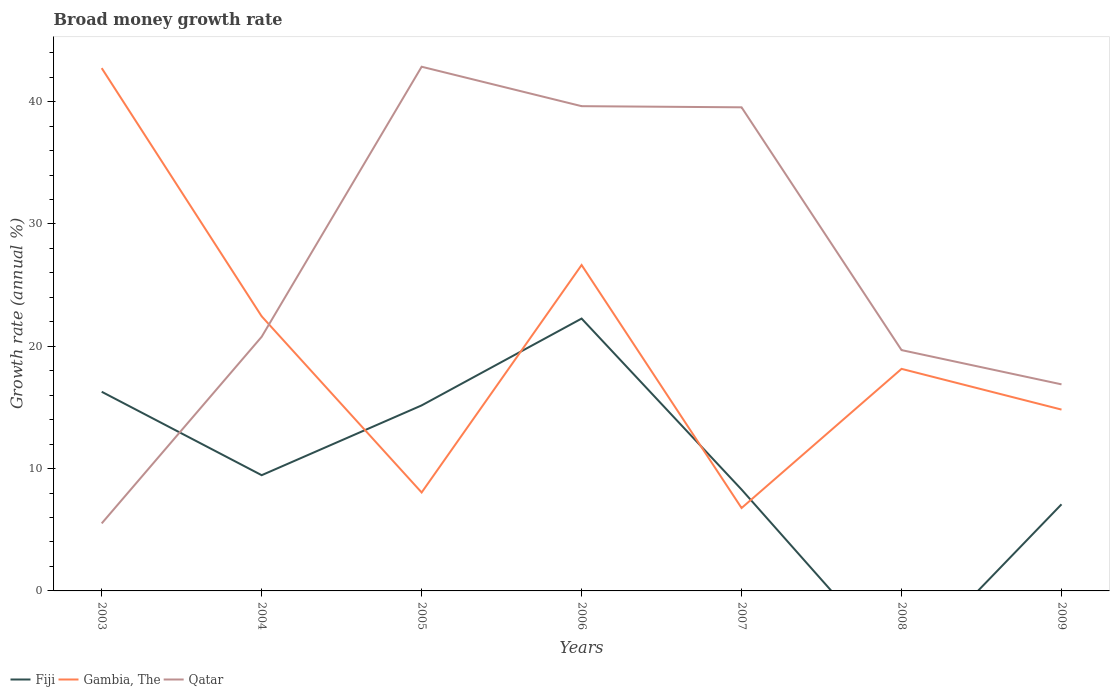Does the line corresponding to Fiji intersect with the line corresponding to Gambia, The?
Offer a terse response. Yes. Is the number of lines equal to the number of legend labels?
Give a very brief answer. No. What is the total growth rate in Gambia, The in the graph?
Provide a succinct answer. 1.27. What is the difference between the highest and the second highest growth rate in Fiji?
Your response must be concise. 22.27. What is the difference between the highest and the lowest growth rate in Fiji?
Keep it short and to the point. 3. How many lines are there?
Keep it short and to the point. 3. Does the graph contain grids?
Your answer should be compact. No. Where does the legend appear in the graph?
Ensure brevity in your answer.  Bottom left. What is the title of the graph?
Offer a very short reply. Broad money growth rate. What is the label or title of the X-axis?
Ensure brevity in your answer.  Years. What is the label or title of the Y-axis?
Keep it short and to the point. Growth rate (annual %). What is the Growth rate (annual %) in Fiji in 2003?
Your response must be concise. 16.28. What is the Growth rate (annual %) in Gambia, The in 2003?
Provide a short and direct response. 42.74. What is the Growth rate (annual %) in Qatar in 2003?
Provide a succinct answer. 5.52. What is the Growth rate (annual %) of Fiji in 2004?
Your answer should be very brief. 9.46. What is the Growth rate (annual %) of Gambia, The in 2004?
Your answer should be very brief. 22.45. What is the Growth rate (annual %) in Qatar in 2004?
Your response must be concise. 20.78. What is the Growth rate (annual %) of Fiji in 2005?
Your response must be concise. 15.17. What is the Growth rate (annual %) in Gambia, The in 2005?
Offer a terse response. 8.05. What is the Growth rate (annual %) in Qatar in 2005?
Ensure brevity in your answer.  42.86. What is the Growth rate (annual %) of Fiji in 2006?
Provide a short and direct response. 22.27. What is the Growth rate (annual %) of Gambia, The in 2006?
Your answer should be very brief. 26.65. What is the Growth rate (annual %) in Qatar in 2006?
Make the answer very short. 39.63. What is the Growth rate (annual %) in Fiji in 2007?
Ensure brevity in your answer.  8.29. What is the Growth rate (annual %) in Gambia, The in 2007?
Your answer should be very brief. 6.78. What is the Growth rate (annual %) of Qatar in 2007?
Your response must be concise. 39.54. What is the Growth rate (annual %) of Fiji in 2008?
Provide a succinct answer. 0. What is the Growth rate (annual %) of Gambia, The in 2008?
Your answer should be very brief. 18.16. What is the Growth rate (annual %) in Qatar in 2008?
Provide a succinct answer. 19.69. What is the Growth rate (annual %) of Fiji in 2009?
Keep it short and to the point. 7.08. What is the Growth rate (annual %) of Gambia, The in 2009?
Offer a very short reply. 14.83. What is the Growth rate (annual %) of Qatar in 2009?
Provide a short and direct response. 16.89. Across all years, what is the maximum Growth rate (annual %) in Fiji?
Keep it short and to the point. 22.27. Across all years, what is the maximum Growth rate (annual %) of Gambia, The?
Your response must be concise. 42.74. Across all years, what is the maximum Growth rate (annual %) of Qatar?
Give a very brief answer. 42.86. Across all years, what is the minimum Growth rate (annual %) of Gambia, The?
Offer a terse response. 6.78. Across all years, what is the minimum Growth rate (annual %) in Qatar?
Make the answer very short. 5.52. What is the total Growth rate (annual %) of Fiji in the graph?
Your answer should be compact. 78.55. What is the total Growth rate (annual %) in Gambia, The in the graph?
Your response must be concise. 139.65. What is the total Growth rate (annual %) of Qatar in the graph?
Keep it short and to the point. 184.91. What is the difference between the Growth rate (annual %) of Fiji in 2003 and that in 2004?
Your answer should be compact. 6.82. What is the difference between the Growth rate (annual %) in Gambia, The in 2003 and that in 2004?
Ensure brevity in your answer.  20.29. What is the difference between the Growth rate (annual %) in Qatar in 2003 and that in 2004?
Provide a short and direct response. -15.26. What is the difference between the Growth rate (annual %) of Fiji in 2003 and that in 2005?
Give a very brief answer. 1.12. What is the difference between the Growth rate (annual %) in Gambia, The in 2003 and that in 2005?
Make the answer very short. 34.69. What is the difference between the Growth rate (annual %) of Qatar in 2003 and that in 2005?
Your answer should be compact. -37.34. What is the difference between the Growth rate (annual %) of Fiji in 2003 and that in 2006?
Offer a terse response. -5.98. What is the difference between the Growth rate (annual %) of Gambia, The in 2003 and that in 2006?
Offer a terse response. 16.1. What is the difference between the Growth rate (annual %) of Qatar in 2003 and that in 2006?
Make the answer very short. -34.11. What is the difference between the Growth rate (annual %) of Fiji in 2003 and that in 2007?
Ensure brevity in your answer.  8. What is the difference between the Growth rate (annual %) of Gambia, The in 2003 and that in 2007?
Ensure brevity in your answer.  35.97. What is the difference between the Growth rate (annual %) in Qatar in 2003 and that in 2007?
Give a very brief answer. -34.02. What is the difference between the Growth rate (annual %) of Gambia, The in 2003 and that in 2008?
Ensure brevity in your answer.  24.59. What is the difference between the Growth rate (annual %) of Qatar in 2003 and that in 2008?
Make the answer very short. -14.17. What is the difference between the Growth rate (annual %) of Fiji in 2003 and that in 2009?
Provide a short and direct response. 9.2. What is the difference between the Growth rate (annual %) in Gambia, The in 2003 and that in 2009?
Your answer should be compact. 27.92. What is the difference between the Growth rate (annual %) of Qatar in 2003 and that in 2009?
Your answer should be compact. -11.37. What is the difference between the Growth rate (annual %) of Fiji in 2004 and that in 2005?
Give a very brief answer. -5.71. What is the difference between the Growth rate (annual %) of Gambia, The in 2004 and that in 2005?
Offer a very short reply. 14.4. What is the difference between the Growth rate (annual %) in Qatar in 2004 and that in 2005?
Your response must be concise. -22.08. What is the difference between the Growth rate (annual %) of Fiji in 2004 and that in 2006?
Make the answer very short. -12.81. What is the difference between the Growth rate (annual %) in Gambia, The in 2004 and that in 2006?
Your response must be concise. -4.19. What is the difference between the Growth rate (annual %) in Qatar in 2004 and that in 2006?
Offer a terse response. -18.86. What is the difference between the Growth rate (annual %) in Fiji in 2004 and that in 2007?
Give a very brief answer. 1.17. What is the difference between the Growth rate (annual %) in Gambia, The in 2004 and that in 2007?
Your answer should be very brief. 15.67. What is the difference between the Growth rate (annual %) of Qatar in 2004 and that in 2007?
Make the answer very short. -18.76. What is the difference between the Growth rate (annual %) of Gambia, The in 2004 and that in 2008?
Offer a very short reply. 4.29. What is the difference between the Growth rate (annual %) in Qatar in 2004 and that in 2008?
Your response must be concise. 1.09. What is the difference between the Growth rate (annual %) in Fiji in 2004 and that in 2009?
Give a very brief answer. 2.38. What is the difference between the Growth rate (annual %) in Gambia, The in 2004 and that in 2009?
Offer a very short reply. 7.62. What is the difference between the Growth rate (annual %) in Qatar in 2004 and that in 2009?
Ensure brevity in your answer.  3.89. What is the difference between the Growth rate (annual %) in Gambia, The in 2005 and that in 2006?
Offer a very short reply. -18.6. What is the difference between the Growth rate (annual %) of Qatar in 2005 and that in 2006?
Your answer should be very brief. 3.22. What is the difference between the Growth rate (annual %) of Fiji in 2005 and that in 2007?
Provide a short and direct response. 6.88. What is the difference between the Growth rate (annual %) of Gambia, The in 2005 and that in 2007?
Your answer should be very brief. 1.27. What is the difference between the Growth rate (annual %) in Qatar in 2005 and that in 2007?
Keep it short and to the point. 3.32. What is the difference between the Growth rate (annual %) in Gambia, The in 2005 and that in 2008?
Your answer should be very brief. -10.11. What is the difference between the Growth rate (annual %) in Qatar in 2005 and that in 2008?
Keep it short and to the point. 23.17. What is the difference between the Growth rate (annual %) in Fiji in 2005 and that in 2009?
Give a very brief answer. 8.09. What is the difference between the Growth rate (annual %) in Gambia, The in 2005 and that in 2009?
Your response must be concise. -6.78. What is the difference between the Growth rate (annual %) in Qatar in 2005 and that in 2009?
Offer a terse response. 25.97. What is the difference between the Growth rate (annual %) in Fiji in 2006 and that in 2007?
Keep it short and to the point. 13.98. What is the difference between the Growth rate (annual %) in Gambia, The in 2006 and that in 2007?
Keep it short and to the point. 19.87. What is the difference between the Growth rate (annual %) of Qatar in 2006 and that in 2007?
Offer a terse response. 0.09. What is the difference between the Growth rate (annual %) of Gambia, The in 2006 and that in 2008?
Keep it short and to the point. 8.49. What is the difference between the Growth rate (annual %) of Qatar in 2006 and that in 2008?
Keep it short and to the point. 19.94. What is the difference between the Growth rate (annual %) of Fiji in 2006 and that in 2009?
Your response must be concise. 15.19. What is the difference between the Growth rate (annual %) in Gambia, The in 2006 and that in 2009?
Provide a succinct answer. 11.82. What is the difference between the Growth rate (annual %) in Qatar in 2006 and that in 2009?
Give a very brief answer. 22.75. What is the difference between the Growth rate (annual %) in Gambia, The in 2007 and that in 2008?
Keep it short and to the point. -11.38. What is the difference between the Growth rate (annual %) of Qatar in 2007 and that in 2008?
Your answer should be compact. 19.85. What is the difference between the Growth rate (annual %) of Fiji in 2007 and that in 2009?
Keep it short and to the point. 1.21. What is the difference between the Growth rate (annual %) of Gambia, The in 2007 and that in 2009?
Your answer should be compact. -8.05. What is the difference between the Growth rate (annual %) of Qatar in 2007 and that in 2009?
Your response must be concise. 22.65. What is the difference between the Growth rate (annual %) of Gambia, The in 2008 and that in 2009?
Offer a very short reply. 3.33. What is the difference between the Growth rate (annual %) of Qatar in 2008 and that in 2009?
Offer a terse response. 2.8. What is the difference between the Growth rate (annual %) in Fiji in 2003 and the Growth rate (annual %) in Gambia, The in 2004?
Provide a short and direct response. -6.17. What is the difference between the Growth rate (annual %) of Fiji in 2003 and the Growth rate (annual %) of Qatar in 2004?
Offer a very short reply. -4.5. What is the difference between the Growth rate (annual %) of Gambia, The in 2003 and the Growth rate (annual %) of Qatar in 2004?
Give a very brief answer. 21.97. What is the difference between the Growth rate (annual %) of Fiji in 2003 and the Growth rate (annual %) of Gambia, The in 2005?
Provide a short and direct response. 8.23. What is the difference between the Growth rate (annual %) in Fiji in 2003 and the Growth rate (annual %) in Qatar in 2005?
Keep it short and to the point. -26.57. What is the difference between the Growth rate (annual %) of Gambia, The in 2003 and the Growth rate (annual %) of Qatar in 2005?
Provide a short and direct response. -0.11. What is the difference between the Growth rate (annual %) in Fiji in 2003 and the Growth rate (annual %) in Gambia, The in 2006?
Provide a succinct answer. -10.36. What is the difference between the Growth rate (annual %) of Fiji in 2003 and the Growth rate (annual %) of Qatar in 2006?
Offer a very short reply. -23.35. What is the difference between the Growth rate (annual %) of Gambia, The in 2003 and the Growth rate (annual %) of Qatar in 2006?
Your answer should be compact. 3.11. What is the difference between the Growth rate (annual %) in Fiji in 2003 and the Growth rate (annual %) in Gambia, The in 2007?
Make the answer very short. 9.51. What is the difference between the Growth rate (annual %) of Fiji in 2003 and the Growth rate (annual %) of Qatar in 2007?
Provide a succinct answer. -23.26. What is the difference between the Growth rate (annual %) of Gambia, The in 2003 and the Growth rate (annual %) of Qatar in 2007?
Provide a succinct answer. 3.2. What is the difference between the Growth rate (annual %) of Fiji in 2003 and the Growth rate (annual %) of Gambia, The in 2008?
Keep it short and to the point. -1.87. What is the difference between the Growth rate (annual %) of Fiji in 2003 and the Growth rate (annual %) of Qatar in 2008?
Offer a terse response. -3.41. What is the difference between the Growth rate (annual %) of Gambia, The in 2003 and the Growth rate (annual %) of Qatar in 2008?
Your answer should be compact. 23.05. What is the difference between the Growth rate (annual %) of Fiji in 2003 and the Growth rate (annual %) of Gambia, The in 2009?
Provide a succinct answer. 1.46. What is the difference between the Growth rate (annual %) in Fiji in 2003 and the Growth rate (annual %) in Qatar in 2009?
Your answer should be compact. -0.61. What is the difference between the Growth rate (annual %) in Gambia, The in 2003 and the Growth rate (annual %) in Qatar in 2009?
Your answer should be very brief. 25.86. What is the difference between the Growth rate (annual %) of Fiji in 2004 and the Growth rate (annual %) of Gambia, The in 2005?
Give a very brief answer. 1.41. What is the difference between the Growth rate (annual %) in Fiji in 2004 and the Growth rate (annual %) in Qatar in 2005?
Keep it short and to the point. -33.4. What is the difference between the Growth rate (annual %) of Gambia, The in 2004 and the Growth rate (annual %) of Qatar in 2005?
Make the answer very short. -20.41. What is the difference between the Growth rate (annual %) of Fiji in 2004 and the Growth rate (annual %) of Gambia, The in 2006?
Your answer should be compact. -17.18. What is the difference between the Growth rate (annual %) in Fiji in 2004 and the Growth rate (annual %) in Qatar in 2006?
Give a very brief answer. -30.17. What is the difference between the Growth rate (annual %) of Gambia, The in 2004 and the Growth rate (annual %) of Qatar in 2006?
Keep it short and to the point. -17.18. What is the difference between the Growth rate (annual %) of Fiji in 2004 and the Growth rate (annual %) of Gambia, The in 2007?
Keep it short and to the point. 2.68. What is the difference between the Growth rate (annual %) in Fiji in 2004 and the Growth rate (annual %) in Qatar in 2007?
Make the answer very short. -30.08. What is the difference between the Growth rate (annual %) of Gambia, The in 2004 and the Growth rate (annual %) of Qatar in 2007?
Your response must be concise. -17.09. What is the difference between the Growth rate (annual %) of Fiji in 2004 and the Growth rate (annual %) of Gambia, The in 2008?
Your answer should be compact. -8.69. What is the difference between the Growth rate (annual %) of Fiji in 2004 and the Growth rate (annual %) of Qatar in 2008?
Offer a very short reply. -10.23. What is the difference between the Growth rate (annual %) of Gambia, The in 2004 and the Growth rate (annual %) of Qatar in 2008?
Offer a very short reply. 2.76. What is the difference between the Growth rate (annual %) of Fiji in 2004 and the Growth rate (annual %) of Gambia, The in 2009?
Provide a short and direct response. -5.36. What is the difference between the Growth rate (annual %) in Fiji in 2004 and the Growth rate (annual %) in Qatar in 2009?
Your answer should be compact. -7.43. What is the difference between the Growth rate (annual %) in Gambia, The in 2004 and the Growth rate (annual %) in Qatar in 2009?
Make the answer very short. 5.56. What is the difference between the Growth rate (annual %) in Fiji in 2005 and the Growth rate (annual %) in Gambia, The in 2006?
Offer a very short reply. -11.48. What is the difference between the Growth rate (annual %) of Fiji in 2005 and the Growth rate (annual %) of Qatar in 2006?
Keep it short and to the point. -24.47. What is the difference between the Growth rate (annual %) in Gambia, The in 2005 and the Growth rate (annual %) in Qatar in 2006?
Make the answer very short. -31.58. What is the difference between the Growth rate (annual %) in Fiji in 2005 and the Growth rate (annual %) in Gambia, The in 2007?
Offer a terse response. 8.39. What is the difference between the Growth rate (annual %) of Fiji in 2005 and the Growth rate (annual %) of Qatar in 2007?
Offer a very short reply. -24.37. What is the difference between the Growth rate (annual %) of Gambia, The in 2005 and the Growth rate (annual %) of Qatar in 2007?
Your answer should be compact. -31.49. What is the difference between the Growth rate (annual %) in Fiji in 2005 and the Growth rate (annual %) in Gambia, The in 2008?
Make the answer very short. -2.99. What is the difference between the Growth rate (annual %) of Fiji in 2005 and the Growth rate (annual %) of Qatar in 2008?
Give a very brief answer. -4.52. What is the difference between the Growth rate (annual %) of Gambia, The in 2005 and the Growth rate (annual %) of Qatar in 2008?
Your answer should be very brief. -11.64. What is the difference between the Growth rate (annual %) of Fiji in 2005 and the Growth rate (annual %) of Gambia, The in 2009?
Your response must be concise. 0.34. What is the difference between the Growth rate (annual %) of Fiji in 2005 and the Growth rate (annual %) of Qatar in 2009?
Provide a succinct answer. -1.72. What is the difference between the Growth rate (annual %) of Gambia, The in 2005 and the Growth rate (annual %) of Qatar in 2009?
Provide a short and direct response. -8.84. What is the difference between the Growth rate (annual %) in Fiji in 2006 and the Growth rate (annual %) in Gambia, The in 2007?
Offer a very short reply. 15.49. What is the difference between the Growth rate (annual %) in Fiji in 2006 and the Growth rate (annual %) in Qatar in 2007?
Your answer should be compact. -17.27. What is the difference between the Growth rate (annual %) of Gambia, The in 2006 and the Growth rate (annual %) of Qatar in 2007?
Your response must be concise. -12.89. What is the difference between the Growth rate (annual %) in Fiji in 2006 and the Growth rate (annual %) in Gambia, The in 2008?
Your response must be concise. 4.11. What is the difference between the Growth rate (annual %) of Fiji in 2006 and the Growth rate (annual %) of Qatar in 2008?
Give a very brief answer. 2.58. What is the difference between the Growth rate (annual %) of Gambia, The in 2006 and the Growth rate (annual %) of Qatar in 2008?
Provide a short and direct response. 6.96. What is the difference between the Growth rate (annual %) in Fiji in 2006 and the Growth rate (annual %) in Gambia, The in 2009?
Your response must be concise. 7.44. What is the difference between the Growth rate (annual %) in Fiji in 2006 and the Growth rate (annual %) in Qatar in 2009?
Your answer should be very brief. 5.38. What is the difference between the Growth rate (annual %) of Gambia, The in 2006 and the Growth rate (annual %) of Qatar in 2009?
Offer a terse response. 9.76. What is the difference between the Growth rate (annual %) in Fiji in 2007 and the Growth rate (annual %) in Gambia, The in 2008?
Make the answer very short. -9.87. What is the difference between the Growth rate (annual %) in Fiji in 2007 and the Growth rate (annual %) in Qatar in 2008?
Your response must be concise. -11.4. What is the difference between the Growth rate (annual %) in Gambia, The in 2007 and the Growth rate (annual %) in Qatar in 2008?
Provide a short and direct response. -12.91. What is the difference between the Growth rate (annual %) in Fiji in 2007 and the Growth rate (annual %) in Gambia, The in 2009?
Give a very brief answer. -6.54. What is the difference between the Growth rate (annual %) in Fiji in 2007 and the Growth rate (annual %) in Qatar in 2009?
Make the answer very short. -8.6. What is the difference between the Growth rate (annual %) in Gambia, The in 2007 and the Growth rate (annual %) in Qatar in 2009?
Provide a succinct answer. -10.11. What is the difference between the Growth rate (annual %) of Gambia, The in 2008 and the Growth rate (annual %) of Qatar in 2009?
Your response must be concise. 1.27. What is the average Growth rate (annual %) in Fiji per year?
Provide a succinct answer. 11.22. What is the average Growth rate (annual %) of Gambia, The per year?
Keep it short and to the point. 19.95. What is the average Growth rate (annual %) in Qatar per year?
Make the answer very short. 26.42. In the year 2003, what is the difference between the Growth rate (annual %) in Fiji and Growth rate (annual %) in Gambia, The?
Offer a very short reply. -26.46. In the year 2003, what is the difference between the Growth rate (annual %) of Fiji and Growth rate (annual %) of Qatar?
Provide a short and direct response. 10.76. In the year 2003, what is the difference between the Growth rate (annual %) in Gambia, The and Growth rate (annual %) in Qatar?
Ensure brevity in your answer.  37.22. In the year 2004, what is the difference between the Growth rate (annual %) in Fiji and Growth rate (annual %) in Gambia, The?
Make the answer very short. -12.99. In the year 2004, what is the difference between the Growth rate (annual %) of Fiji and Growth rate (annual %) of Qatar?
Offer a terse response. -11.32. In the year 2004, what is the difference between the Growth rate (annual %) in Gambia, The and Growth rate (annual %) in Qatar?
Your response must be concise. 1.67. In the year 2005, what is the difference between the Growth rate (annual %) in Fiji and Growth rate (annual %) in Gambia, The?
Ensure brevity in your answer.  7.12. In the year 2005, what is the difference between the Growth rate (annual %) in Fiji and Growth rate (annual %) in Qatar?
Keep it short and to the point. -27.69. In the year 2005, what is the difference between the Growth rate (annual %) in Gambia, The and Growth rate (annual %) in Qatar?
Your response must be concise. -34.81. In the year 2006, what is the difference between the Growth rate (annual %) of Fiji and Growth rate (annual %) of Gambia, The?
Make the answer very short. -4.38. In the year 2006, what is the difference between the Growth rate (annual %) of Fiji and Growth rate (annual %) of Qatar?
Provide a short and direct response. -17.37. In the year 2006, what is the difference between the Growth rate (annual %) in Gambia, The and Growth rate (annual %) in Qatar?
Make the answer very short. -12.99. In the year 2007, what is the difference between the Growth rate (annual %) in Fiji and Growth rate (annual %) in Gambia, The?
Provide a short and direct response. 1.51. In the year 2007, what is the difference between the Growth rate (annual %) in Fiji and Growth rate (annual %) in Qatar?
Your answer should be compact. -31.25. In the year 2007, what is the difference between the Growth rate (annual %) of Gambia, The and Growth rate (annual %) of Qatar?
Your response must be concise. -32.76. In the year 2008, what is the difference between the Growth rate (annual %) in Gambia, The and Growth rate (annual %) in Qatar?
Offer a terse response. -1.53. In the year 2009, what is the difference between the Growth rate (annual %) of Fiji and Growth rate (annual %) of Gambia, The?
Your response must be concise. -7.74. In the year 2009, what is the difference between the Growth rate (annual %) of Fiji and Growth rate (annual %) of Qatar?
Your answer should be very brief. -9.81. In the year 2009, what is the difference between the Growth rate (annual %) in Gambia, The and Growth rate (annual %) in Qatar?
Keep it short and to the point. -2.06. What is the ratio of the Growth rate (annual %) of Fiji in 2003 to that in 2004?
Your answer should be compact. 1.72. What is the ratio of the Growth rate (annual %) in Gambia, The in 2003 to that in 2004?
Ensure brevity in your answer.  1.9. What is the ratio of the Growth rate (annual %) in Qatar in 2003 to that in 2004?
Ensure brevity in your answer.  0.27. What is the ratio of the Growth rate (annual %) in Fiji in 2003 to that in 2005?
Ensure brevity in your answer.  1.07. What is the ratio of the Growth rate (annual %) of Gambia, The in 2003 to that in 2005?
Make the answer very short. 5.31. What is the ratio of the Growth rate (annual %) in Qatar in 2003 to that in 2005?
Offer a terse response. 0.13. What is the ratio of the Growth rate (annual %) of Fiji in 2003 to that in 2006?
Give a very brief answer. 0.73. What is the ratio of the Growth rate (annual %) in Gambia, The in 2003 to that in 2006?
Provide a short and direct response. 1.6. What is the ratio of the Growth rate (annual %) in Qatar in 2003 to that in 2006?
Provide a short and direct response. 0.14. What is the ratio of the Growth rate (annual %) in Fiji in 2003 to that in 2007?
Provide a short and direct response. 1.96. What is the ratio of the Growth rate (annual %) of Gambia, The in 2003 to that in 2007?
Keep it short and to the point. 6.31. What is the ratio of the Growth rate (annual %) in Qatar in 2003 to that in 2007?
Your answer should be very brief. 0.14. What is the ratio of the Growth rate (annual %) of Gambia, The in 2003 to that in 2008?
Ensure brevity in your answer.  2.35. What is the ratio of the Growth rate (annual %) in Qatar in 2003 to that in 2008?
Your response must be concise. 0.28. What is the ratio of the Growth rate (annual %) in Fiji in 2003 to that in 2009?
Your response must be concise. 2.3. What is the ratio of the Growth rate (annual %) in Gambia, The in 2003 to that in 2009?
Keep it short and to the point. 2.88. What is the ratio of the Growth rate (annual %) of Qatar in 2003 to that in 2009?
Offer a very short reply. 0.33. What is the ratio of the Growth rate (annual %) in Fiji in 2004 to that in 2005?
Provide a short and direct response. 0.62. What is the ratio of the Growth rate (annual %) of Gambia, The in 2004 to that in 2005?
Make the answer very short. 2.79. What is the ratio of the Growth rate (annual %) in Qatar in 2004 to that in 2005?
Your answer should be compact. 0.48. What is the ratio of the Growth rate (annual %) in Fiji in 2004 to that in 2006?
Make the answer very short. 0.42. What is the ratio of the Growth rate (annual %) in Gambia, The in 2004 to that in 2006?
Provide a short and direct response. 0.84. What is the ratio of the Growth rate (annual %) of Qatar in 2004 to that in 2006?
Your response must be concise. 0.52. What is the ratio of the Growth rate (annual %) of Fiji in 2004 to that in 2007?
Your answer should be very brief. 1.14. What is the ratio of the Growth rate (annual %) of Gambia, The in 2004 to that in 2007?
Ensure brevity in your answer.  3.31. What is the ratio of the Growth rate (annual %) in Qatar in 2004 to that in 2007?
Offer a very short reply. 0.53. What is the ratio of the Growth rate (annual %) in Gambia, The in 2004 to that in 2008?
Your answer should be compact. 1.24. What is the ratio of the Growth rate (annual %) in Qatar in 2004 to that in 2008?
Give a very brief answer. 1.06. What is the ratio of the Growth rate (annual %) of Fiji in 2004 to that in 2009?
Offer a very short reply. 1.34. What is the ratio of the Growth rate (annual %) in Gambia, The in 2004 to that in 2009?
Keep it short and to the point. 1.51. What is the ratio of the Growth rate (annual %) in Qatar in 2004 to that in 2009?
Give a very brief answer. 1.23. What is the ratio of the Growth rate (annual %) in Fiji in 2005 to that in 2006?
Give a very brief answer. 0.68. What is the ratio of the Growth rate (annual %) in Gambia, The in 2005 to that in 2006?
Your answer should be compact. 0.3. What is the ratio of the Growth rate (annual %) of Qatar in 2005 to that in 2006?
Provide a short and direct response. 1.08. What is the ratio of the Growth rate (annual %) in Fiji in 2005 to that in 2007?
Offer a terse response. 1.83. What is the ratio of the Growth rate (annual %) of Gambia, The in 2005 to that in 2007?
Keep it short and to the point. 1.19. What is the ratio of the Growth rate (annual %) of Qatar in 2005 to that in 2007?
Your answer should be compact. 1.08. What is the ratio of the Growth rate (annual %) of Gambia, The in 2005 to that in 2008?
Give a very brief answer. 0.44. What is the ratio of the Growth rate (annual %) in Qatar in 2005 to that in 2008?
Provide a short and direct response. 2.18. What is the ratio of the Growth rate (annual %) in Fiji in 2005 to that in 2009?
Offer a very short reply. 2.14. What is the ratio of the Growth rate (annual %) of Gambia, The in 2005 to that in 2009?
Keep it short and to the point. 0.54. What is the ratio of the Growth rate (annual %) in Qatar in 2005 to that in 2009?
Your response must be concise. 2.54. What is the ratio of the Growth rate (annual %) of Fiji in 2006 to that in 2007?
Your answer should be compact. 2.69. What is the ratio of the Growth rate (annual %) of Gambia, The in 2006 to that in 2007?
Give a very brief answer. 3.93. What is the ratio of the Growth rate (annual %) in Gambia, The in 2006 to that in 2008?
Give a very brief answer. 1.47. What is the ratio of the Growth rate (annual %) of Qatar in 2006 to that in 2008?
Provide a succinct answer. 2.01. What is the ratio of the Growth rate (annual %) in Fiji in 2006 to that in 2009?
Make the answer very short. 3.14. What is the ratio of the Growth rate (annual %) of Gambia, The in 2006 to that in 2009?
Ensure brevity in your answer.  1.8. What is the ratio of the Growth rate (annual %) in Qatar in 2006 to that in 2009?
Ensure brevity in your answer.  2.35. What is the ratio of the Growth rate (annual %) of Gambia, The in 2007 to that in 2008?
Make the answer very short. 0.37. What is the ratio of the Growth rate (annual %) of Qatar in 2007 to that in 2008?
Make the answer very short. 2.01. What is the ratio of the Growth rate (annual %) of Fiji in 2007 to that in 2009?
Provide a succinct answer. 1.17. What is the ratio of the Growth rate (annual %) of Gambia, The in 2007 to that in 2009?
Keep it short and to the point. 0.46. What is the ratio of the Growth rate (annual %) of Qatar in 2007 to that in 2009?
Provide a short and direct response. 2.34. What is the ratio of the Growth rate (annual %) in Gambia, The in 2008 to that in 2009?
Provide a succinct answer. 1.22. What is the ratio of the Growth rate (annual %) of Qatar in 2008 to that in 2009?
Your response must be concise. 1.17. What is the difference between the highest and the second highest Growth rate (annual %) in Fiji?
Offer a very short reply. 5.98. What is the difference between the highest and the second highest Growth rate (annual %) in Gambia, The?
Ensure brevity in your answer.  16.1. What is the difference between the highest and the second highest Growth rate (annual %) of Qatar?
Keep it short and to the point. 3.22. What is the difference between the highest and the lowest Growth rate (annual %) of Fiji?
Ensure brevity in your answer.  22.27. What is the difference between the highest and the lowest Growth rate (annual %) in Gambia, The?
Your response must be concise. 35.97. What is the difference between the highest and the lowest Growth rate (annual %) of Qatar?
Keep it short and to the point. 37.34. 